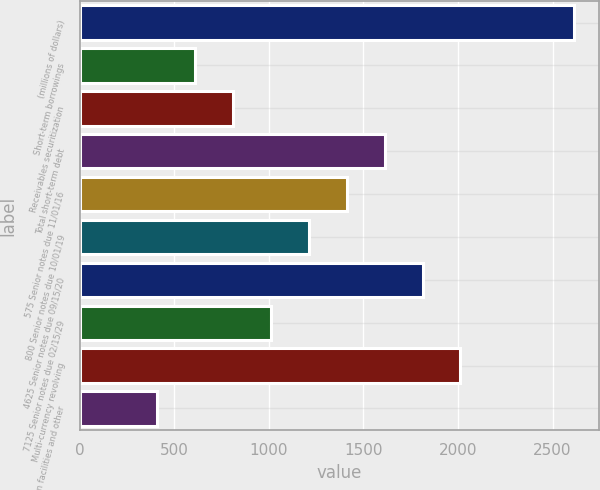Convert chart. <chart><loc_0><loc_0><loc_500><loc_500><bar_chart><fcel>(millions of dollars)<fcel>Short-term borrowings<fcel>Receivables securitization<fcel>Total short-term debt<fcel>575 Senior notes due 11/01/16<fcel>800 Senior notes due 10/01/19<fcel>4625 Senior notes due 09/15/20<fcel>7125 Senior notes due 02/15/29<fcel>Multi-currency revolving<fcel>Term loan facilities and other<nl><fcel>2614.86<fcel>608.66<fcel>809.28<fcel>1611.76<fcel>1411.14<fcel>1210.52<fcel>1812.38<fcel>1009.9<fcel>2013<fcel>408.04<nl></chart> 